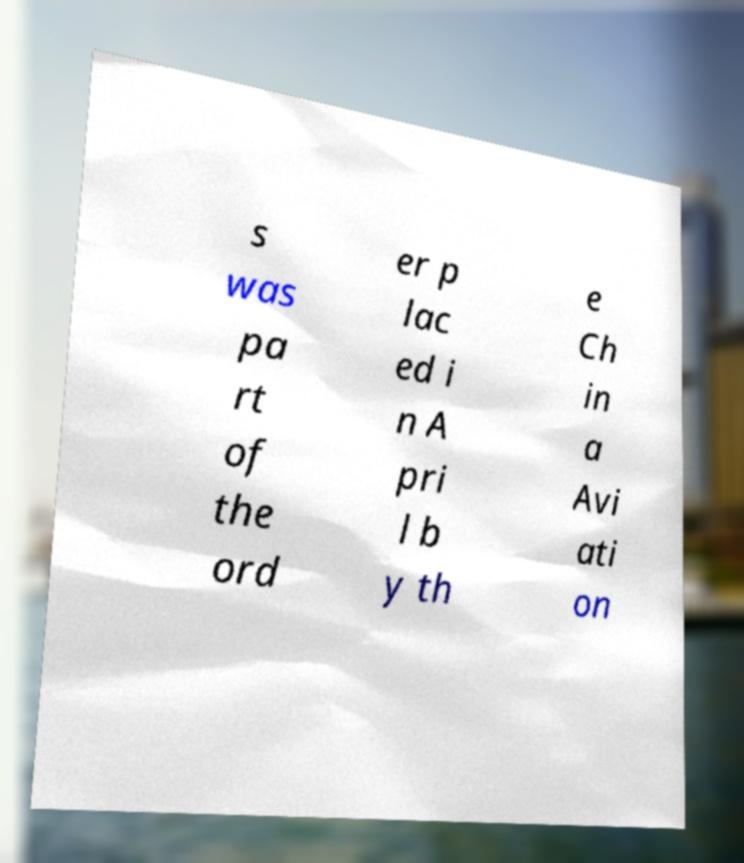Please identify and transcribe the text found in this image. s was pa rt of the ord er p lac ed i n A pri l b y th e Ch in a Avi ati on 